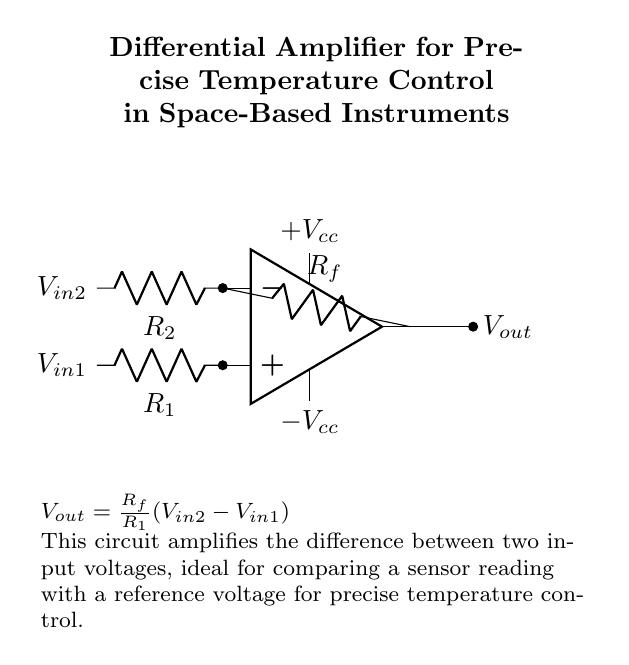What type of amplifier is shown in the diagram? The circuit shown is a differential amplifier, characterized by its ability to amplify the difference between two input voltages. This is evident from the labeling of the input terminals as V-in1 and V-in2.
Answer: Differential amplifier What is the output voltage formula for this circuit? The output voltage is given by the formula V-out equals R-f over R-1 times the difference between V-in2 and V-in1. This is stated in the explanation section of the diagram, providing direct insight into the operation of the amplifier.
Answer: V-out equals R-f over R-1 times the difference between V-in2 and V-in1 What are the values of the resistors R-1 and R-2? The resistors R-1 and R-2 are identified as essential components in the input section of the amplifier, however, specific numerical values for these resistors are not provided in the diagram or description. Therefore, they are generalized as R-1 and R-2 without specific quantities.
Answer: Not specified What is the purpose of the feedback resistor R-f? The feedback resistor R-f is crucial as it determines the gain of the amplifier. It controls how much of the output voltage is fed back to the inverting input, influencing the overall amplification effect in conjunction with R-1.
Answer: Determines gain What are the supply voltages for this amplifier circuit? The power supply voltages are labeled as plus V-cc and minus V-cc, indicating that the amplifier requires a dual-polarity supply to operate, which is common in operational amplifier circuits.
Answer: Plus V-cc and minus V-cc How does this amplifier achieve precise temperature control? The differential amplifier compares the voltage from a temperature sensor with a reference voltage, allowing for precise temperature measurement and control as indicated by its use in space-based instruments to monitor and adjust conditions effectively.
Answer: Compares sensor voltage 